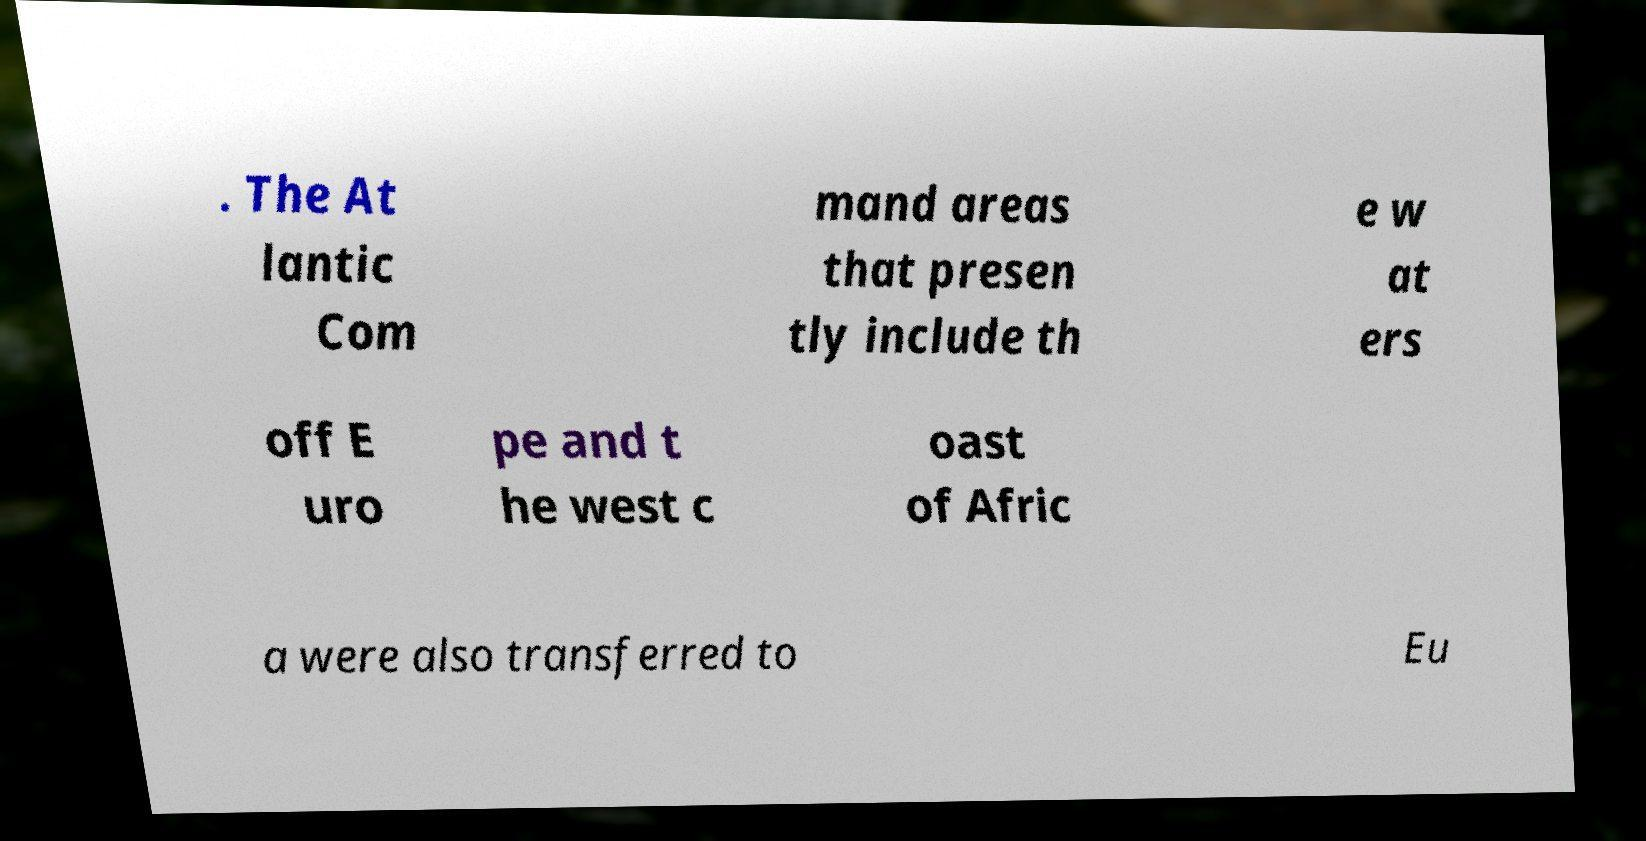Please identify and transcribe the text found in this image. . The At lantic Com mand areas that presen tly include th e w at ers off E uro pe and t he west c oast of Afric a were also transferred to Eu 